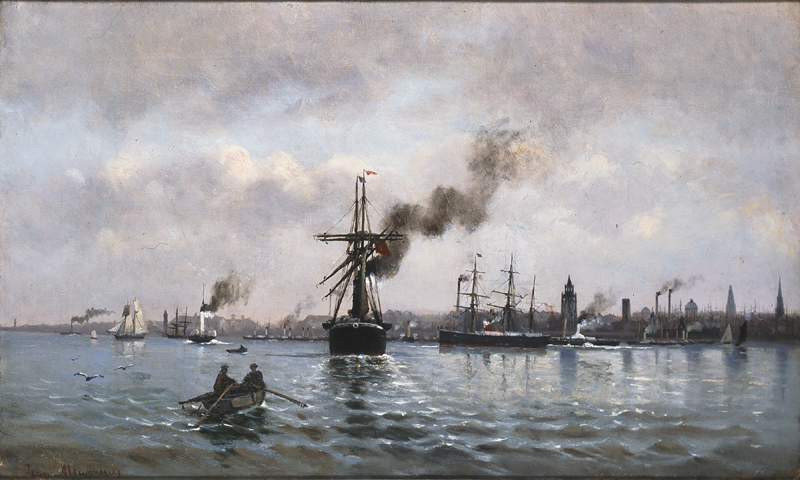What do you see happening in this image? The image vividly captures a busy harbor scene dominated by a large ship emitting a plume of black smoke. Surrounding this central vessel are various types of boats, including sailboats and tugboats, bustling within the harbor. The muted color palette adds a vintage feel, suggesting it could be from the 19th century. The choppy waters indicate windy conditions, and the cloudy sky contributes to a somber mood. The detailed artwork falls into the marine art genre, renowned for its depiction of maritime activities and oceanic scenery. 